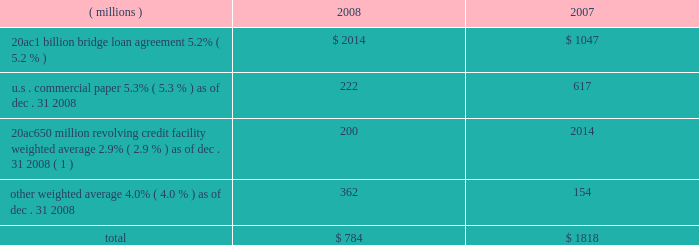Notes to the consolidated financial statements on march 18 , 2008 , ppg completed a public offering of $ 600 million in aggregate principal amount of its 5.75% ( 5.75 % ) notes due 2013 ( the 201c2013 notes 201d ) , $ 700 million in aggregate principal amount of its 6.65% ( 6.65 % ) notes due 2018 ( the 201c2018 notes 201d ) and $ 250 million in aggregate principal amount of its 7.70% ( 7.70 % ) notes due 2038 ( the 201c2038 notes 201d and , together with the 2013 notes and the 2018 notes , the 201cnotes 201d ) .
The notes were offered by the company pursuant to its existing shelf registration .
The proceeds of this offering of $ 1538 million ( net of discount and issuance costs ) and additional borrowings of $ 195 million under the 20ac650 million revolving credit facility were used to repay existing debt , including certain short-term debt and the amounts outstanding under the 20ac1 billion bridge loan .
No further amounts can be borrowed under the 20ac1 billion bridge loan .
The discount and issuance costs related to the notes , which totaled $ 12 million , will be amortized to interest expense over the respective lives of the notes .
Short-term debt outstanding as of december 31 , 2008 and 2007 , was as follows : ( millions ) 2008 2007 .
Total $ 784 $ 1818 ( 1 ) borrowings under this facility have a term of 30 days and can be rolled over monthly until the facility expires in 2010 .
Ppg is in compliance with the restrictive covenants under its various credit agreements , loan agreements and indentures .
The company 2019s revolving credit agreements include a financial ratio covenant .
The covenant requires that the amount of total indebtedness not exceed 60% ( 60 % ) of the company 2019s total capitalization excluding the portion of accumulated other comprehensive income ( loss ) related to pensions and other postretirement benefit adjustments .
As of december 31 , 2008 , total indebtedness was 45% ( 45 % ) of the company 2019s total capitalization excluding the portion of accumulated other comprehensive income ( loss ) related to pensions and other postretirement benefit adjustments .
Additionally , substantially all of the company 2019s debt agreements contain customary cross- default provisions .
Those provisions generally provide that a default on a debt service payment of $ 10 million or more for longer than the grace period provided ( usually 10 days ) under one agreement may result in an event of default under other agreements .
None of the company 2019s primary debt obligations are secured or guaranteed by the company 2019s affiliates .
Interest payments in 2008 , 2007 and 2006 totaled $ 228 million , $ 102 million and $ 90 million , respectively .
Rental expense for operating leases was $ 267 million , $ 188 million and $ 161 million in 2008 , 2007 and 2006 , respectively .
The primary leased assets include paint stores , transportation equipment , warehouses and other distribution facilities , and office space , including the company 2019s corporate headquarters located in pittsburgh , pa .
Minimum lease commitments for operating leases that have initial or remaining lease terms in excess of one year as of december 31 , 2008 , are ( in millions ) $ 126 in 2009 , $ 107 in 2010 , $ 82 in 2011 , $ 65 in 2012 , $ 51 in 2013 and $ 202 thereafter .
The company had outstanding letters of credit of $ 82 million as of december 31 , 2008 .
The letters of credit secure the company 2019s performance to third parties under certain self-insurance programs and other commitments made in the ordinary course of business .
As of december 31 , 2008 and 2007 guarantees outstanding were $ 70 million .
The guarantees relate primarily to debt of certain entities in which ppg has an ownership interest and selected customers of certain of the company 2019s businesses .
A portion of such debt is secured by the assets of the related entities .
The carrying values of these guarantees were $ 9 million and $ 3 million as of december 31 , 2008 and 2007 , respectively , and the fair values were $ 40 million and $ 17 million , as of december 31 , 2008 and 2007 , respectively .
The company does not believe any loss related to these letters of credit or guarantees is likely .
10 .
Financial instruments , excluding derivative financial instruments included in ppg 2019s financial instrument portfolio are cash and cash equivalents , cash held in escrow , marketable equity securities , company-owned life insurance and short- and long-term debt instruments .
The fair values of the financial instruments approximated their carrying values , in the aggregate , except for long-term long-term debt ( excluding capital lease obligations ) , had carrying and fair values totaling $ 3122 million and $ 3035 million , respectively , as of december 31 , 2008 .
The corresponding amounts as of december 31 , 2007 , were $ 1201 million and $ 1226 million , respectively .
The fair values of the debt instruments were based on discounted cash flows and interest rates currently available to the company for instruments of the same remaining maturities .
2008 ppg annual report and form 10-k 45 .
As of december 31 , 2008 , what would be the cash flow impact if the guarantees and letters of credit were called , in millions? 
Computations: (82 + 70)
Answer: 152.0. 